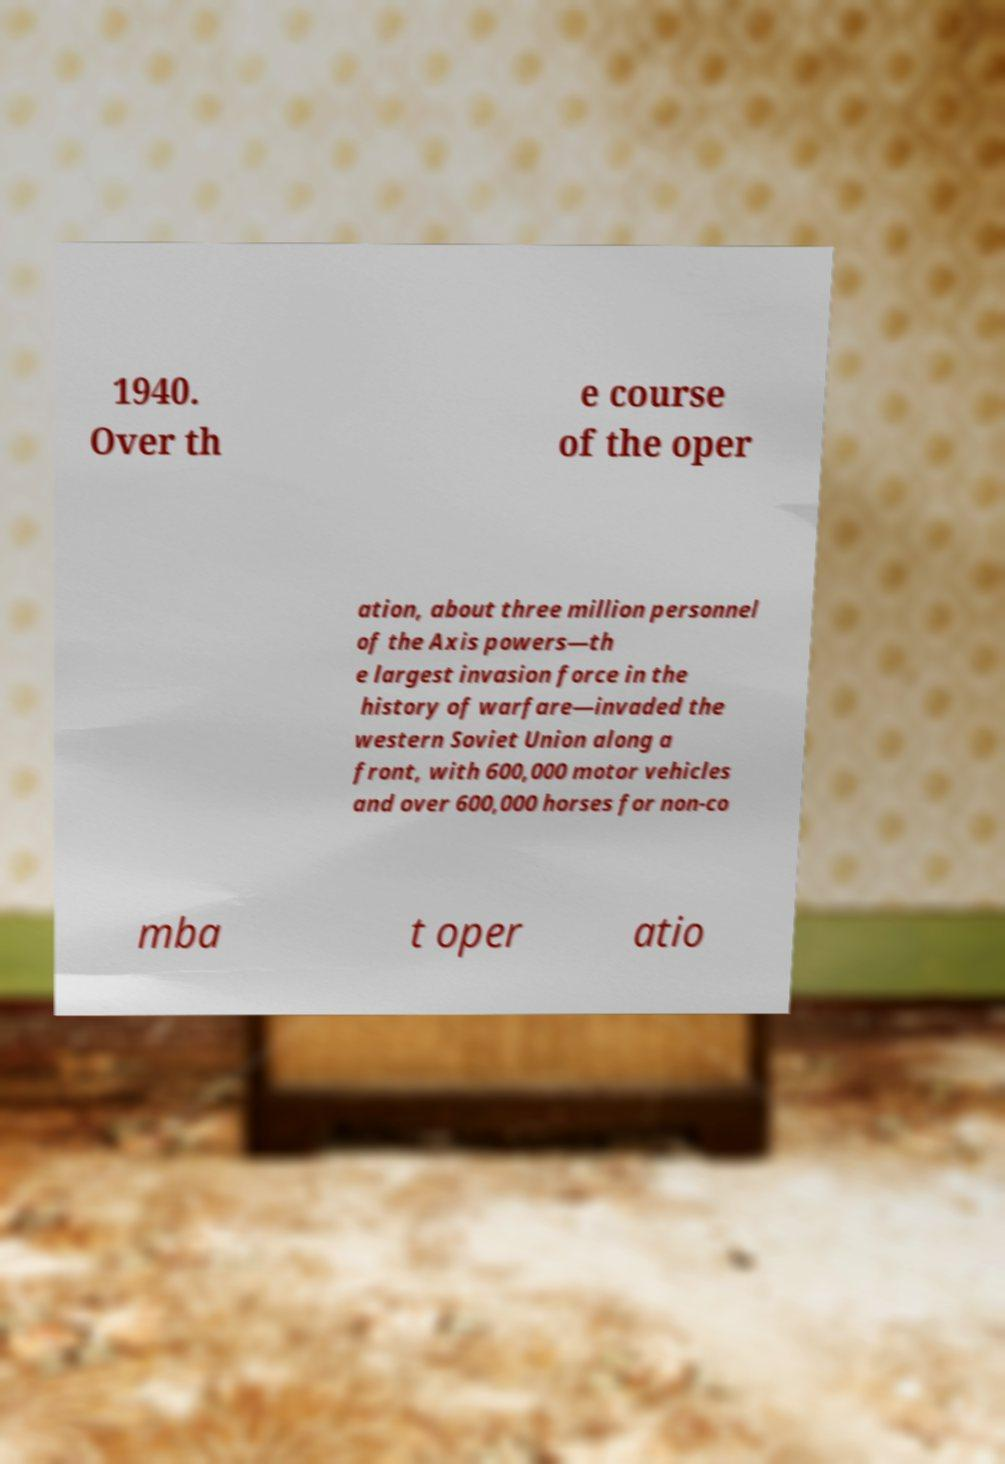Can you read and provide the text displayed in the image?This photo seems to have some interesting text. Can you extract and type it out for me? 1940. Over th e course of the oper ation, about three million personnel of the Axis powers—th e largest invasion force in the history of warfare—invaded the western Soviet Union along a front, with 600,000 motor vehicles and over 600,000 horses for non-co mba t oper atio 